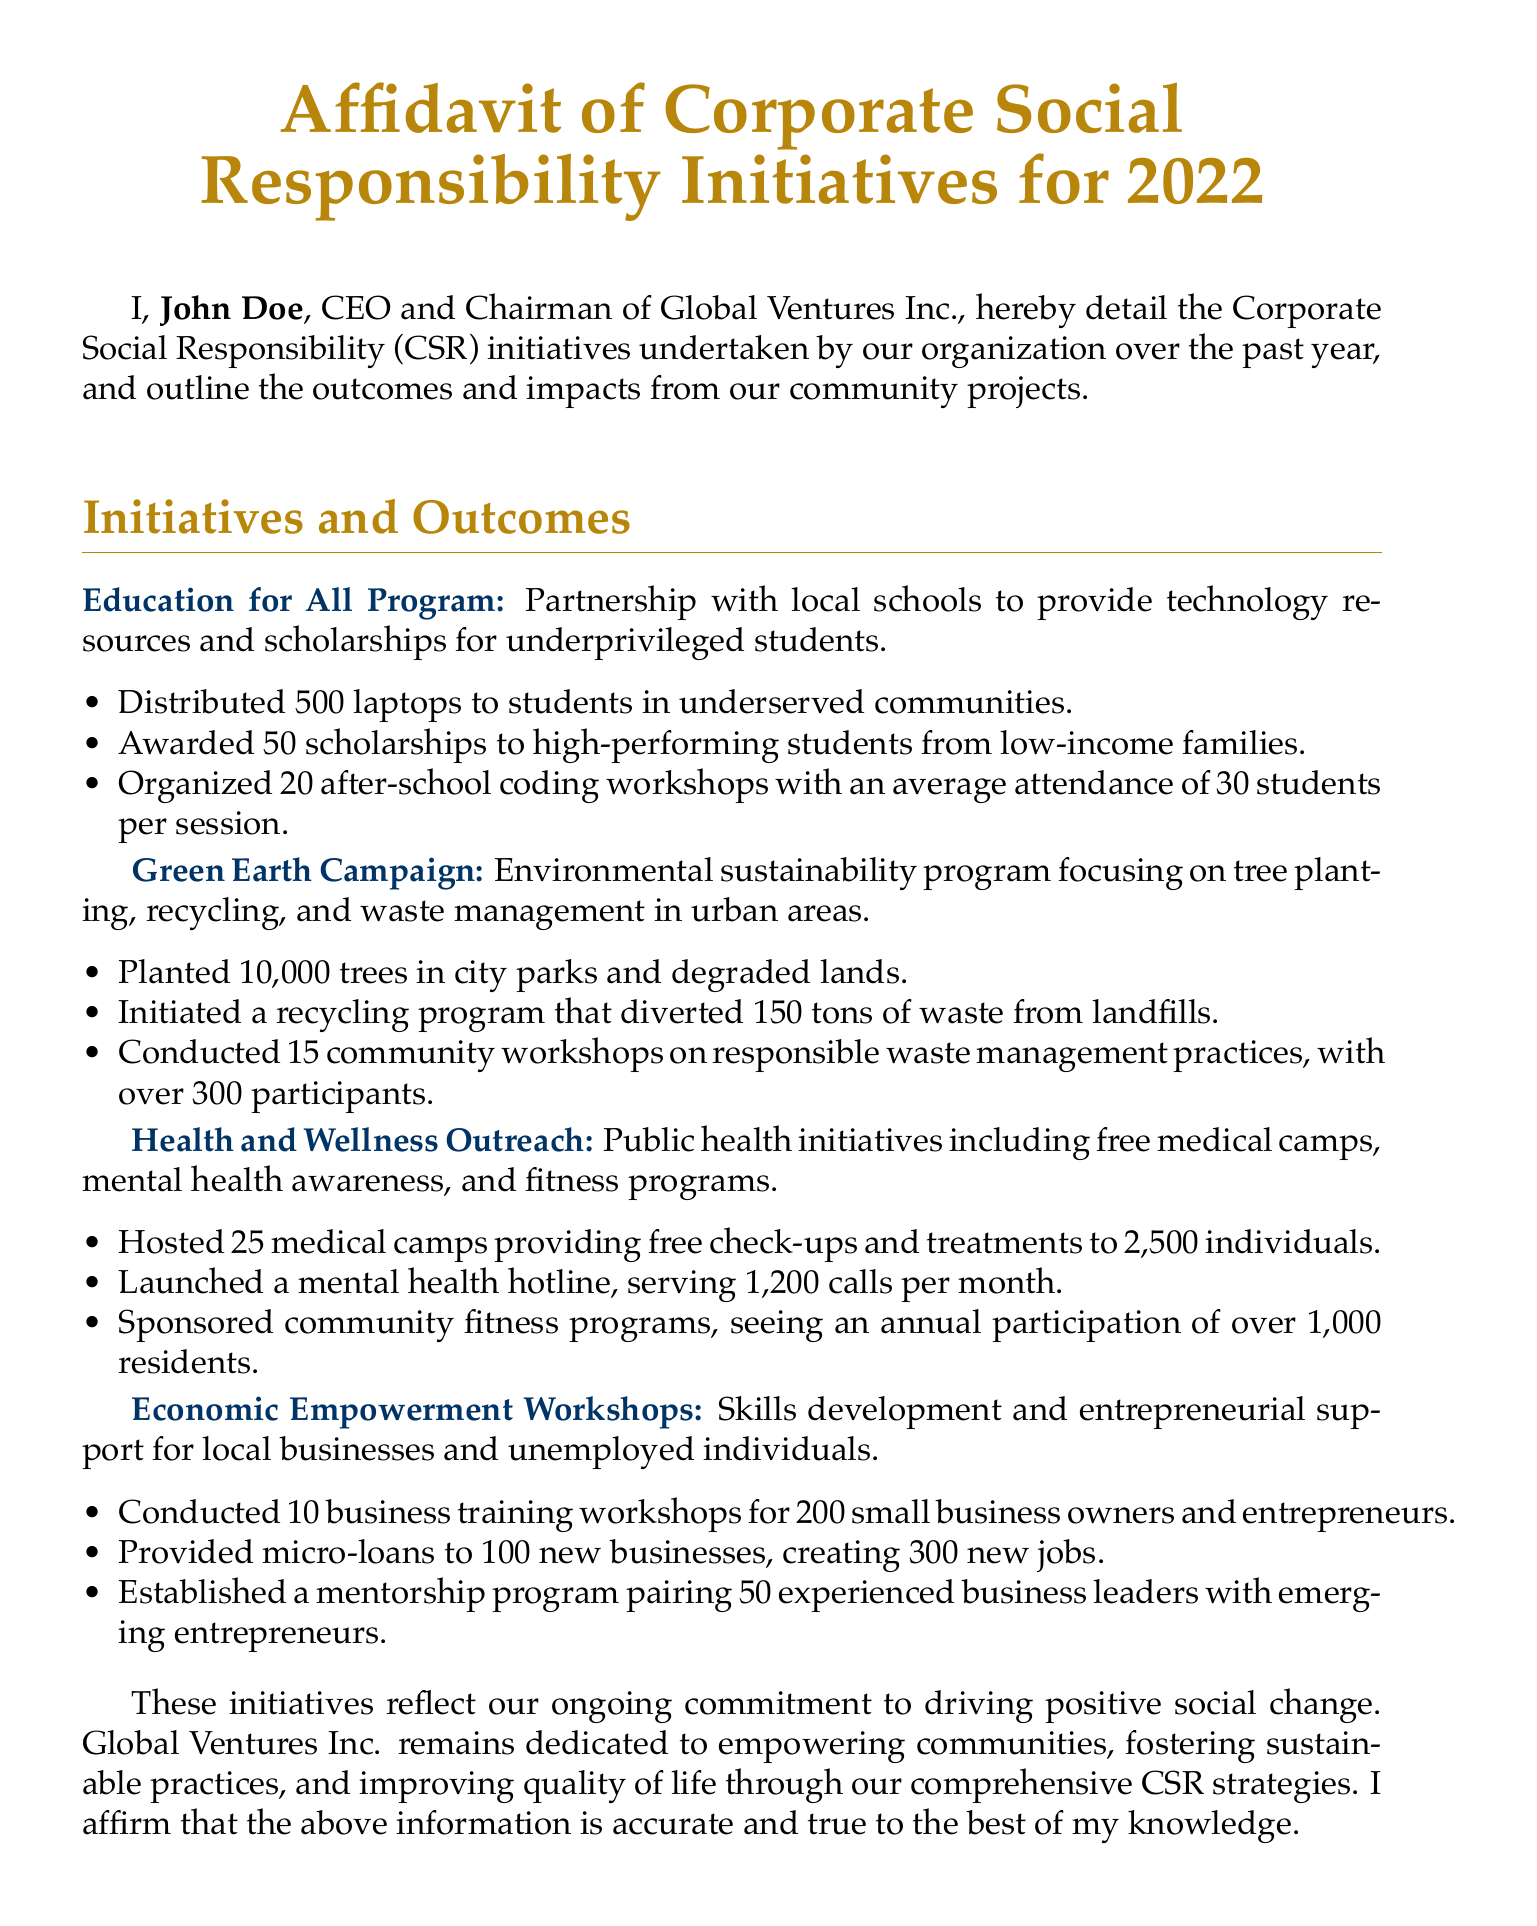What is the name of the CEO of Global Ventures Inc.? The CEO and Chairman of Global Ventures Inc. is named John Doe.
Answer: John Doe How many laptops were distributed in the Education for All Program? The number of laptops distributed under this initiative is stated clearly in the document.
Answer: 500 What is the total number of trees planted in the Green Earth Campaign? The document specifies the total number of trees planted as part of the initiative.
Answer: 10,000 How many medical camps were hosted in the Health and Wellness Outreach? The count of medical camps organized for this initiative is mentioned in the document.
Answer: 25 What percentage of participants attended the community workshops on waste management? To calculate this, knowing the number of participants and the expected average capacity helps deduce participation rates. Given that there were 15 workshops with over 300 participants, it's noted in context as a success.
Answer: over 300 participants What type of financial aid was given to new businesses in the Economic Empowerment Workshops? The document indicates a specific type of financial support aimed at promoting business growth.
Answer: micro-loans On what date was this affidavit signed? The date on which John Doe signed the affidavit is clearly stated at the end of the document.
Answer: September 30, 2023 What commitment does Global Ventures Inc. affirm in this document? The document emphasizes a broad commitment by the organization regarding social change and community support.
Answer: driving positive social change How many community workshops were conducted in the Green Earth Campaign? The document specifically lists the number of workshops held for this initiative.
Answer: 15 